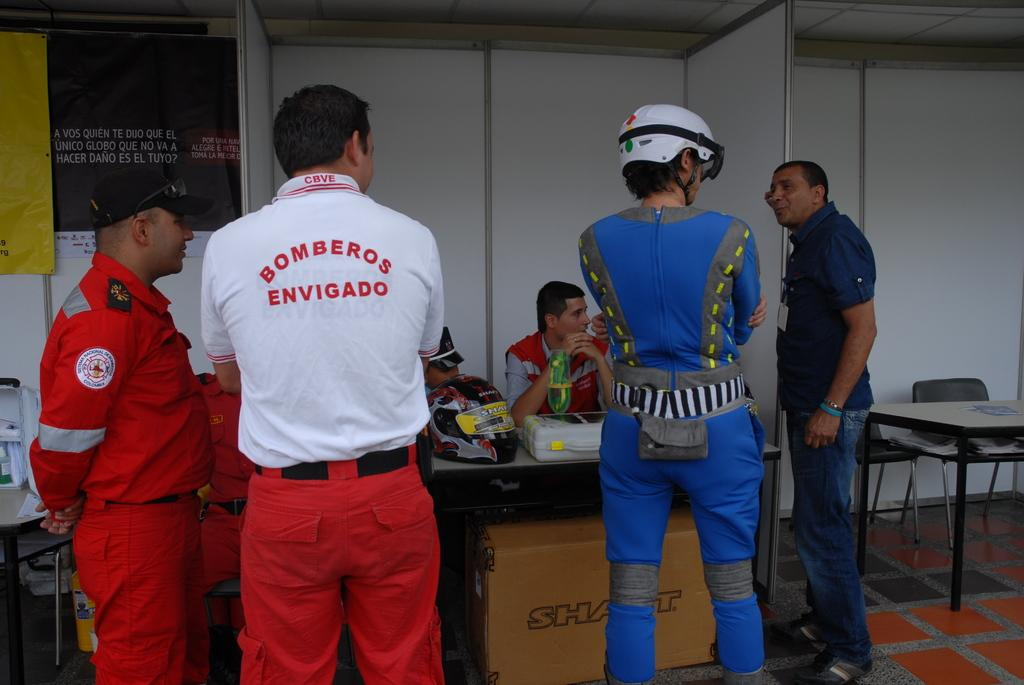Provide a one-sentence caption for the provided image. A group of people and one is wearing a bomberos shirt. 